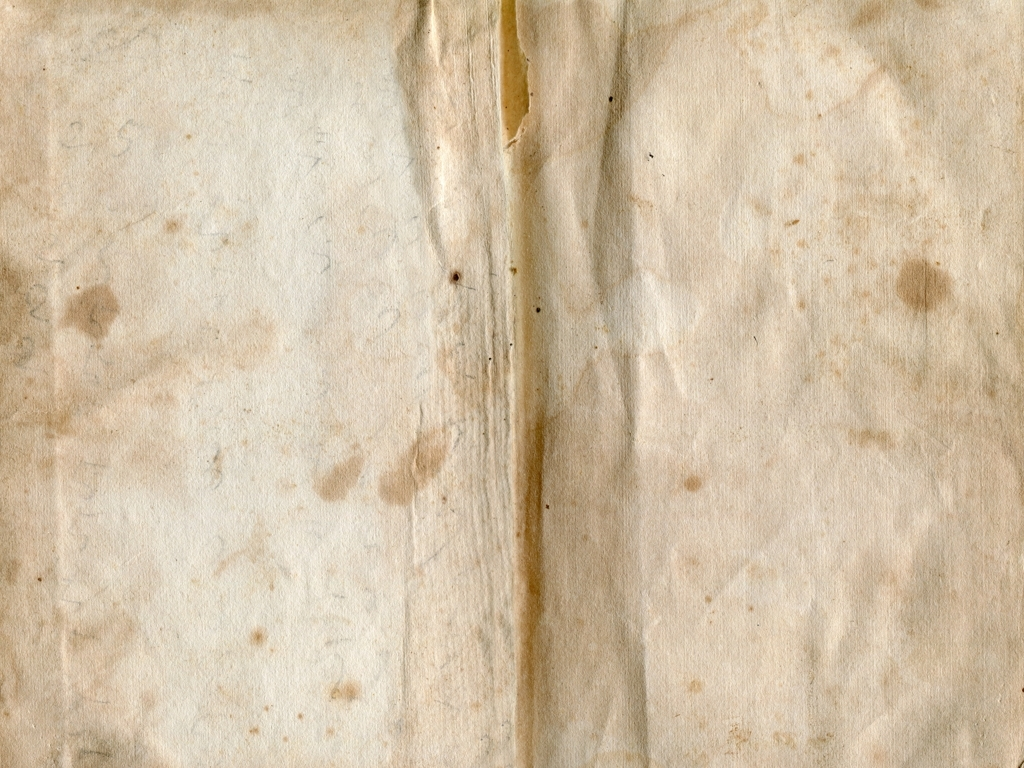Can you speculate about the historical period this paper might be from based on its appearance? The paper in the image has a distinctly aged look with discoloration and spots, which may suggest it could be from an earlier century, perhaps the 18th or 19th century. However, without more context or specific markings, it's difficult to accurately determine the exact period. 